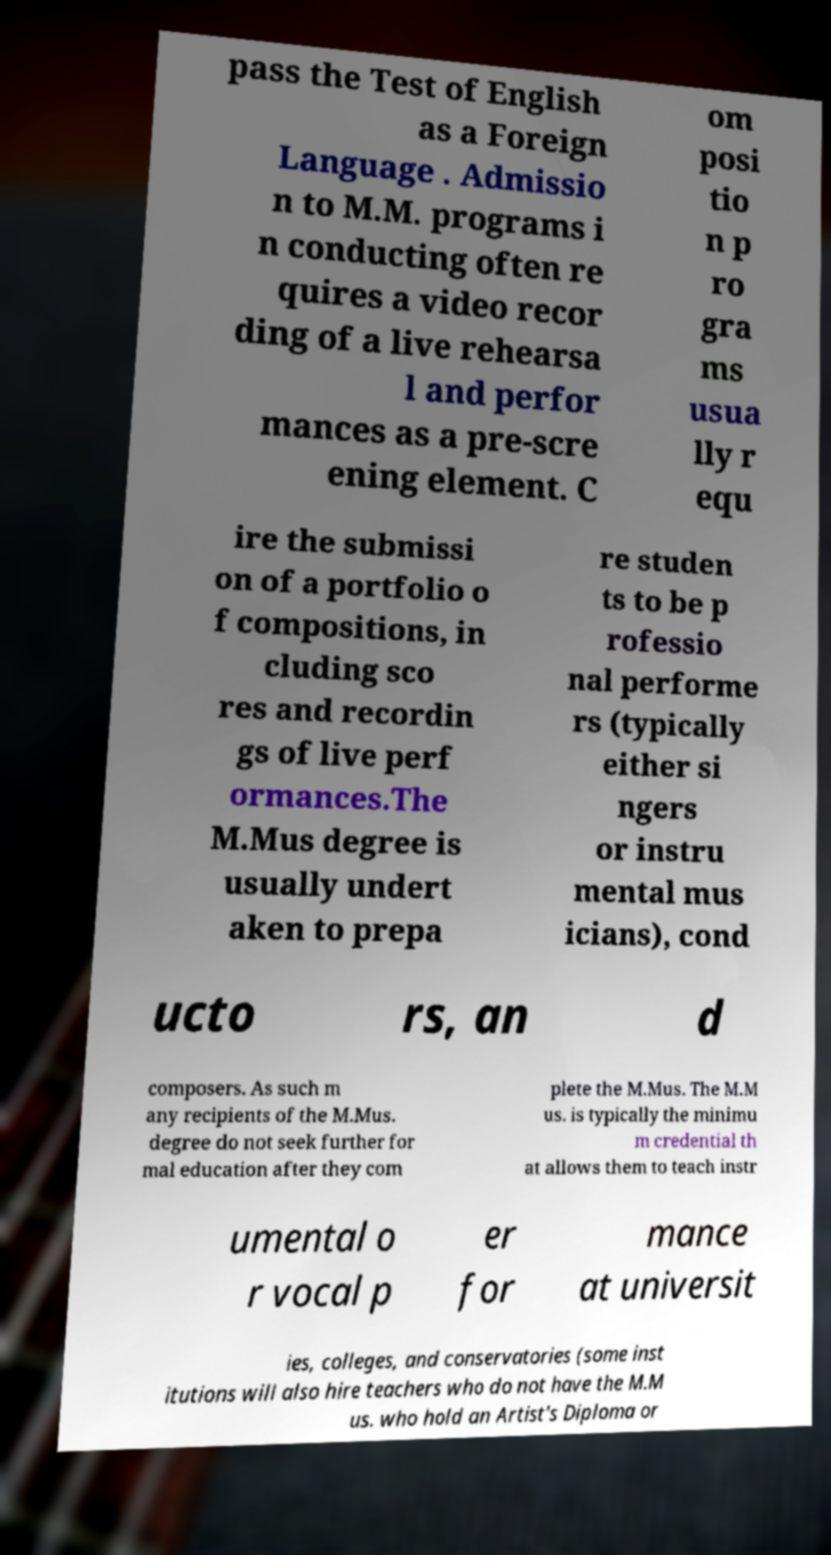For documentation purposes, I need the text within this image transcribed. Could you provide that? pass the Test of English as a Foreign Language . Admissio n to M.M. programs i n conducting often re quires a video recor ding of a live rehearsa l and perfor mances as a pre-scre ening element. C om posi tio n p ro gra ms usua lly r equ ire the submissi on of a portfolio o f compositions, in cluding sco res and recordin gs of live perf ormances.The M.Mus degree is usually undert aken to prepa re studen ts to be p rofessio nal performe rs (typically either si ngers or instru mental mus icians), cond ucto rs, an d composers. As such m any recipients of the M.Mus. degree do not seek further for mal education after they com plete the M.Mus. The M.M us. is typically the minimu m credential th at allows them to teach instr umental o r vocal p er for mance at universit ies, colleges, and conservatories (some inst itutions will also hire teachers who do not have the M.M us. who hold an Artist's Diploma or 